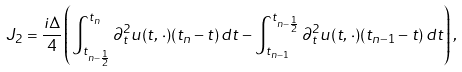<formula> <loc_0><loc_0><loc_500><loc_500>J _ { 2 } = \frac { i \Delta } { 4 } \left ( \int _ { t _ { n - \frac { 1 } { 2 } } } ^ { t _ { n } } \partial _ { t } ^ { 2 } u ( t , \, \cdot ) ( t _ { n } - t ) \, d t - \int _ { t _ { n - 1 } } ^ { t _ { n - \frac { 1 } { 2 } } } \partial _ { t } ^ { 2 } u ( t , \, \cdot ) ( t _ { n - 1 } - t ) \, d t \right ) ,</formula> 